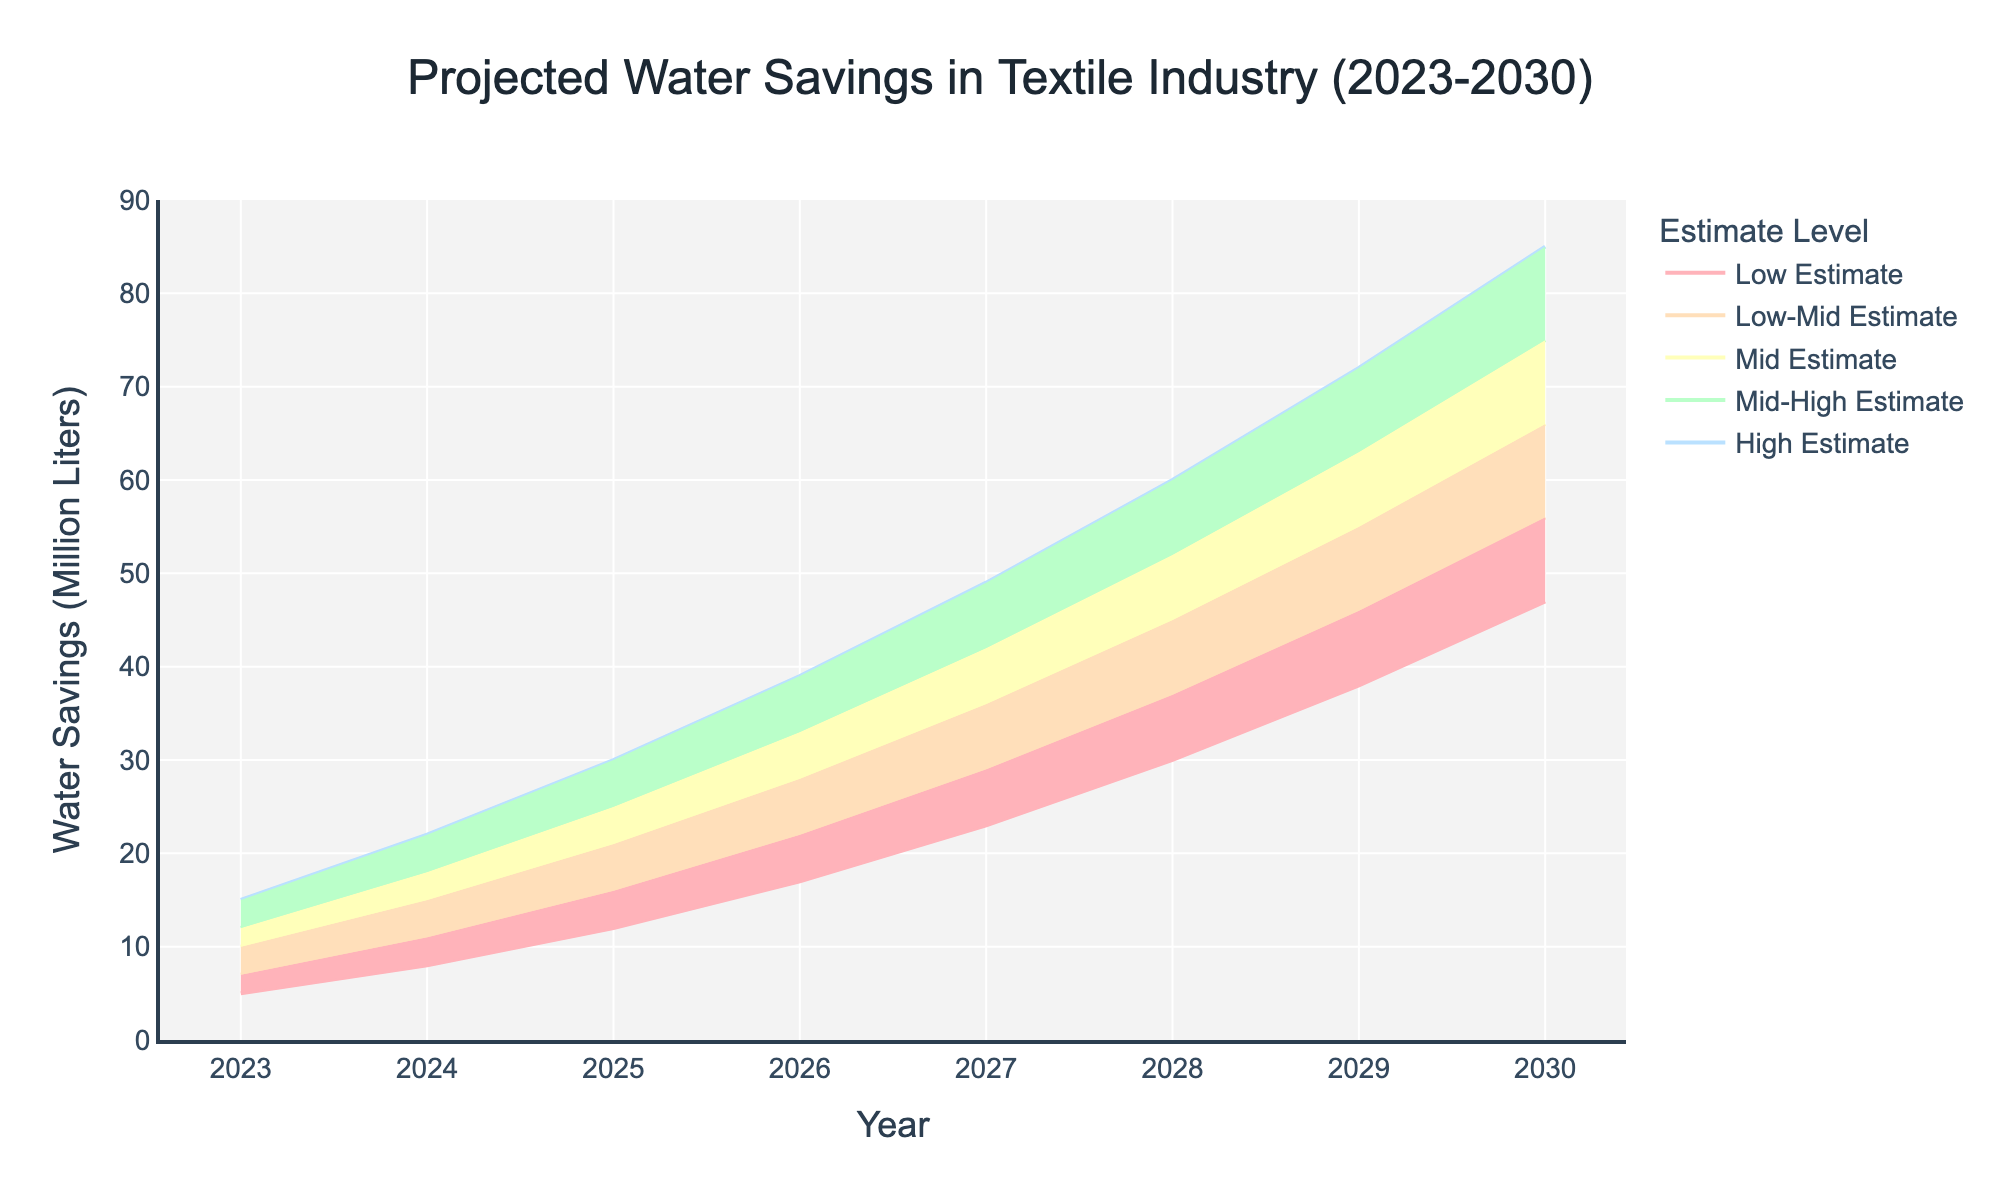What is the title of the chart? The title of the chart is placed at the top and explicitly states the purpose of the chart. Here, it is "Projected Water Savings in Textile Industry (2023-2030)."
Answer: Projected Water Savings in Textile Industry (2023-2030) Which year shows the highest water savings in the 'High Estimate' scenario? To find the year with the highest water savings in the 'High Estimate' scenario, we locate the endpoint of the 'High Estimate' line. According to the chart, 2030 has the highest value in this scenario.
Answer: 2030 What are the projected water savings for the 'Mid Estimate' in 2026? Look at the intersection point of 2026 on the x-axis and the 'Mid Estimate' line, which falls exactly at 28 million liters.
Answer: 28 million liters What is the difference between the 'High Estimate' and 'Low Estimate' for the year 2025? Find the projected values for both the 'High Estimate' and 'Low Estimate' for 2025. The 'High Estimate' is at 30 million liters, and the 'Low Estimate' is at 12 million liters. The difference is 30 - 12 = 18 million liters.
Answer: 18 million liters How does the projected water savings trend from 2023 to 2030 in the 'Low Estimate'? Observe the trajectory of the 'Low Estimate' line from 2023 to 2030. It shows a consistent upward trend, starting from 5 million liters in 2023 and reaching 47 million liters in 2030.
Answer: Upward trend Which estimate shows the largest projected increase from 2023 to 2024? Compare the increments between 2023 and 2024 for all estimate levels. The 'High Estimate' increases the most, from 15 million liters in 2023 to 22 million liters in 2024, a difference of 7 million liters.
Answer: High Estimate In 2029, which two estimates have a difference of 10 million liters between them? Referring to 2029, check the differences between all adjacent estimates. The 'Low-Mid Estimate' is 46 million liters, and the 'Mid Estimate' is 55 million liters, making a difference of 9 million liters, close to 10 million liters as other adjacent differences are either below or above 10.
Answer: Low-Mid Estimate and Mid Estimate What is the range of projected water savings in 2028 for all estimates? Examine the projected values for all estimates in 2028. The lowest value is the 'Low Estimate' at 30 million liters, and the highest is the 'High Estimate' at 60 million liters. The range is 60 - 30 = 30 million liters.
Answer: 30 million liters Between which consecutive years is the largest increase in water savings projected for the 'Mid-High Estimate'? Identify the increments for the 'Mid-High Estimate' between consecutive years and find the largest one. From 2025 to 2026, the increase is from 25 million liters to 33 million liters, an 8 million liters increment, which is the largest.
Answer: 2025 to 2026 How do the ranges between the 'Low Estimate' and 'High Estimate' change over the years? Determine the range (difference) between the 'Low Estimate' and 'High Estimate' for each year. Notice that the range progressively increases from 10 million liters in 2023 to 38 million liters in 2030, showing a widening trend.
Answer: Widening trend 